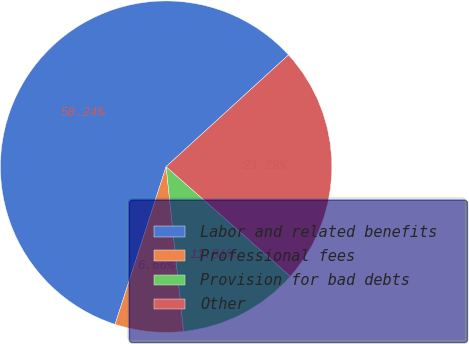<chart> <loc_0><loc_0><loc_500><loc_500><pie_chart><fcel>Labor and related benefits<fcel>Professional fees<fcel>Provision for bad debts<fcel>Other<nl><fcel>58.24%<fcel>6.66%<fcel>11.81%<fcel>23.29%<nl></chart> 